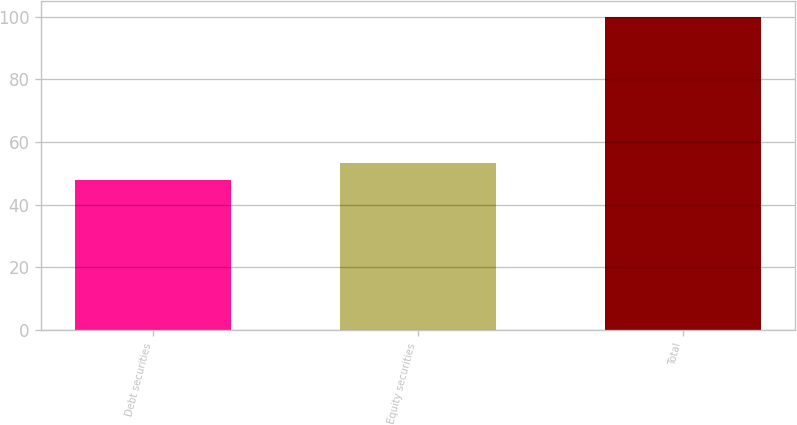Convert chart to OTSL. <chart><loc_0><loc_0><loc_500><loc_500><bar_chart><fcel>Debt securities<fcel>Equity securities<fcel>Total<nl><fcel>48<fcel>53.2<fcel>100<nl></chart> 